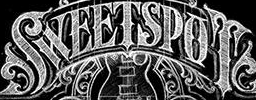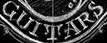Read the text content from these images in order, separated by a semicolon. SWEETSPOT; GUITARS 